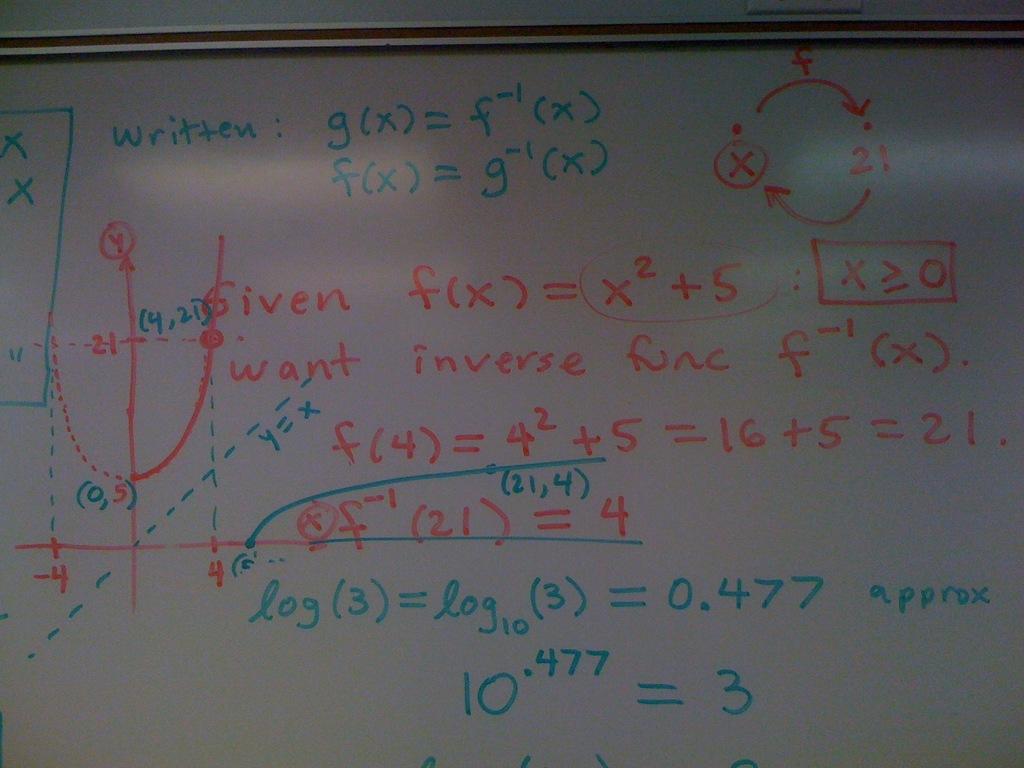What does 10.477 equal?
Provide a short and direct response. 3. 